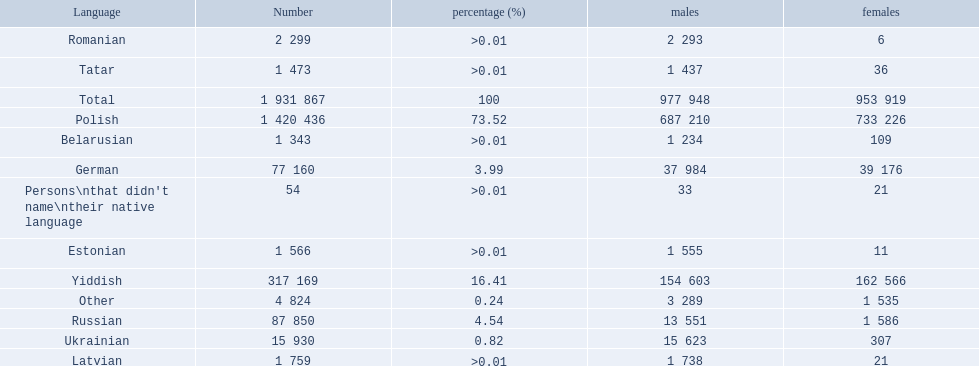What languages are spoken in the warsaw governorate? Polish, Yiddish, Russian, German, Ukrainian, Romanian, Latvian, Estonian, Tatar, Belarusian, Other, Persons\nthat didn't name\ntheir native language. What is the number for russian? 87 850. On this list what is the next lowest number? 77 160. Which language has a number of 77160 speakers? German. 